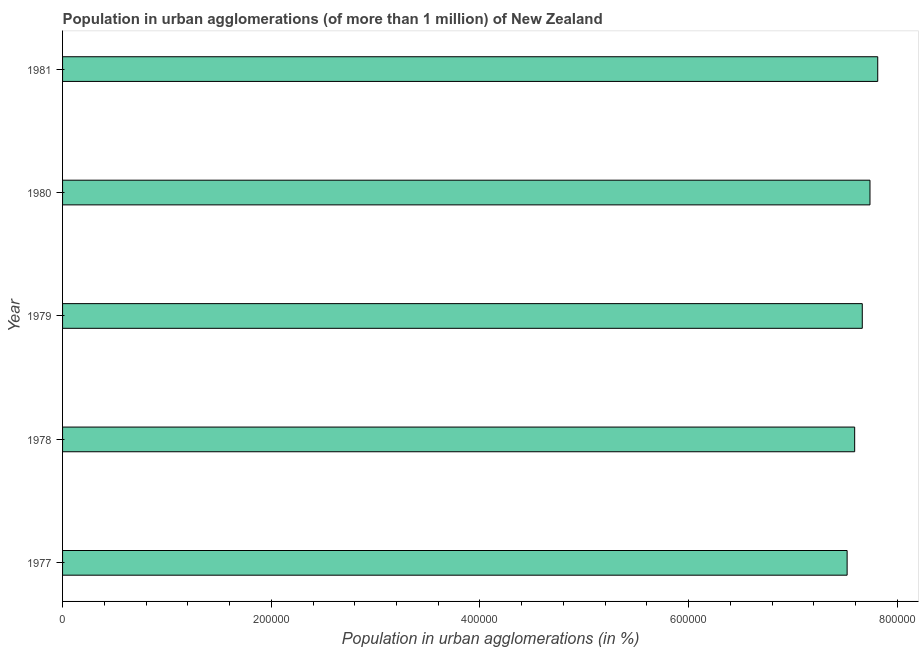Does the graph contain grids?
Make the answer very short. No. What is the title of the graph?
Offer a very short reply. Population in urban agglomerations (of more than 1 million) of New Zealand. What is the label or title of the X-axis?
Offer a terse response. Population in urban agglomerations (in %). What is the label or title of the Y-axis?
Offer a very short reply. Year. What is the population in urban agglomerations in 1979?
Keep it short and to the point. 7.66e+05. Across all years, what is the maximum population in urban agglomerations?
Make the answer very short. 7.81e+05. Across all years, what is the minimum population in urban agglomerations?
Provide a short and direct response. 7.52e+05. In which year was the population in urban agglomerations maximum?
Your response must be concise. 1981. In which year was the population in urban agglomerations minimum?
Ensure brevity in your answer.  1977. What is the sum of the population in urban agglomerations?
Provide a short and direct response. 3.83e+06. What is the difference between the population in urban agglomerations in 1979 and 1980?
Your answer should be very brief. -7377. What is the average population in urban agglomerations per year?
Make the answer very short. 7.66e+05. What is the median population in urban agglomerations?
Provide a succinct answer. 7.66e+05. In how many years, is the population in urban agglomerations greater than 440000 %?
Offer a very short reply. 5. Do a majority of the years between 1979 and 1980 (inclusive) have population in urban agglomerations greater than 640000 %?
Your answer should be compact. Yes. What is the ratio of the population in urban agglomerations in 1978 to that in 1981?
Ensure brevity in your answer.  0.97. Is the population in urban agglomerations in 1977 less than that in 1978?
Give a very brief answer. Yes. Is the difference between the population in urban agglomerations in 1978 and 1980 greater than the difference between any two years?
Give a very brief answer. No. What is the difference between the highest and the second highest population in urban agglomerations?
Offer a very short reply. 7427. What is the difference between the highest and the lowest population in urban agglomerations?
Offer a very short reply. 2.93e+04. In how many years, is the population in urban agglomerations greater than the average population in urban agglomerations taken over all years?
Keep it short and to the point. 2. How many bars are there?
Your answer should be compact. 5. How many years are there in the graph?
Give a very brief answer. 5. What is the difference between two consecutive major ticks on the X-axis?
Offer a very short reply. 2.00e+05. Are the values on the major ticks of X-axis written in scientific E-notation?
Provide a succinct answer. No. What is the Population in urban agglomerations (in %) in 1977?
Your answer should be very brief. 7.52e+05. What is the Population in urban agglomerations (in %) of 1978?
Your answer should be very brief. 7.59e+05. What is the Population in urban agglomerations (in %) of 1979?
Ensure brevity in your answer.  7.66e+05. What is the Population in urban agglomerations (in %) of 1980?
Give a very brief answer. 7.74e+05. What is the Population in urban agglomerations (in %) of 1981?
Provide a succinct answer. 7.81e+05. What is the difference between the Population in urban agglomerations (in %) in 1977 and 1978?
Provide a succinct answer. -7227. What is the difference between the Population in urban agglomerations (in %) in 1977 and 1979?
Your answer should be very brief. -1.45e+04. What is the difference between the Population in urban agglomerations (in %) in 1977 and 1980?
Offer a terse response. -2.19e+04. What is the difference between the Population in urban agglomerations (in %) in 1977 and 1981?
Ensure brevity in your answer.  -2.93e+04. What is the difference between the Population in urban agglomerations (in %) in 1978 and 1979?
Keep it short and to the point. -7297. What is the difference between the Population in urban agglomerations (in %) in 1978 and 1980?
Provide a succinct answer. -1.47e+04. What is the difference between the Population in urban agglomerations (in %) in 1978 and 1981?
Ensure brevity in your answer.  -2.21e+04. What is the difference between the Population in urban agglomerations (in %) in 1979 and 1980?
Provide a short and direct response. -7377. What is the difference between the Population in urban agglomerations (in %) in 1979 and 1981?
Provide a short and direct response. -1.48e+04. What is the difference between the Population in urban agglomerations (in %) in 1980 and 1981?
Keep it short and to the point. -7427. What is the ratio of the Population in urban agglomerations (in %) in 1977 to that in 1978?
Your answer should be very brief. 0.99. What is the ratio of the Population in urban agglomerations (in %) in 1977 to that in 1980?
Give a very brief answer. 0.97. What is the ratio of the Population in urban agglomerations (in %) in 1977 to that in 1981?
Ensure brevity in your answer.  0.96. What is the ratio of the Population in urban agglomerations (in %) in 1978 to that in 1981?
Provide a succinct answer. 0.97. What is the ratio of the Population in urban agglomerations (in %) in 1979 to that in 1981?
Your answer should be very brief. 0.98. 